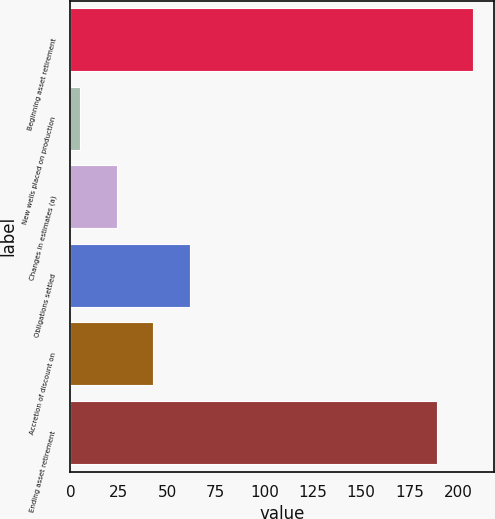Convert chart to OTSL. <chart><loc_0><loc_0><loc_500><loc_500><bar_chart><fcel>Beginning asset retirement<fcel>New wells placed on production<fcel>Changes in estimates (a)<fcel>Obligations settled<fcel>Accretion of discount on<fcel>Ending asset retirement<nl><fcel>207.9<fcel>5<fcel>23.9<fcel>61.7<fcel>42.8<fcel>189<nl></chart> 